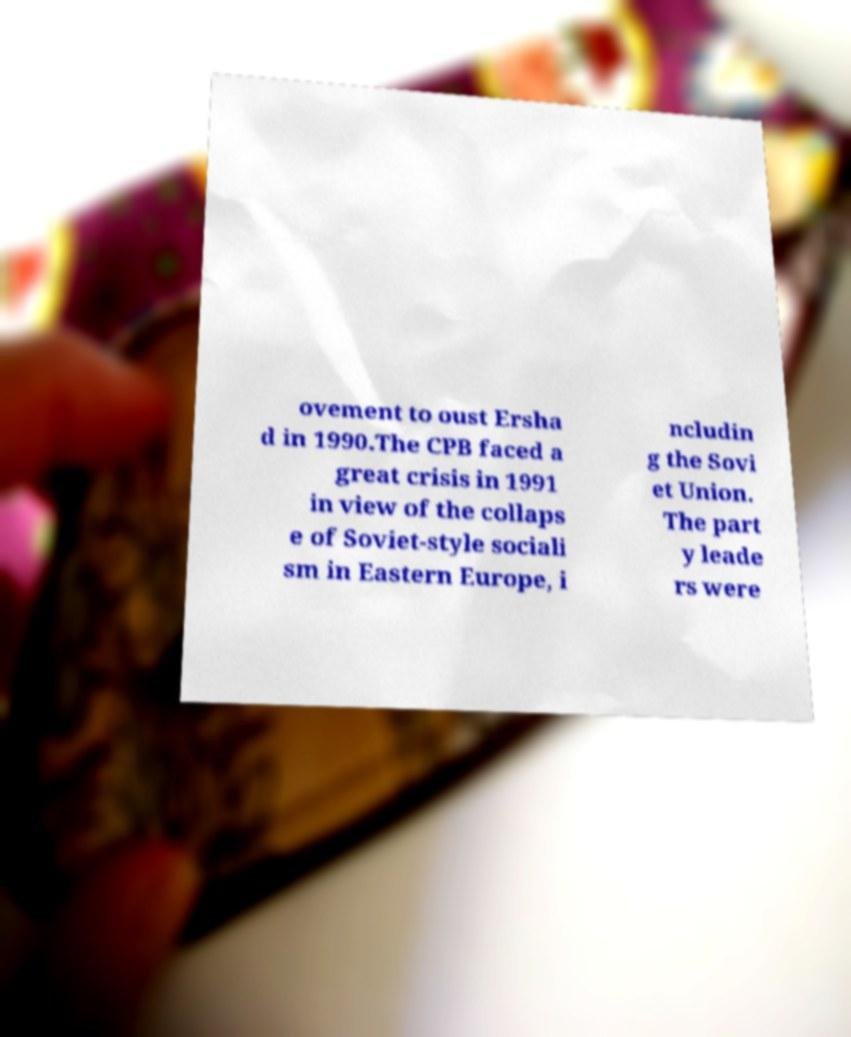Could you assist in decoding the text presented in this image and type it out clearly? ovement to oust Ersha d in 1990.The CPB faced a great crisis in 1991 in view of the collaps e of Soviet-style sociali sm in Eastern Europe, i ncludin g the Sovi et Union. The part y leade rs were 